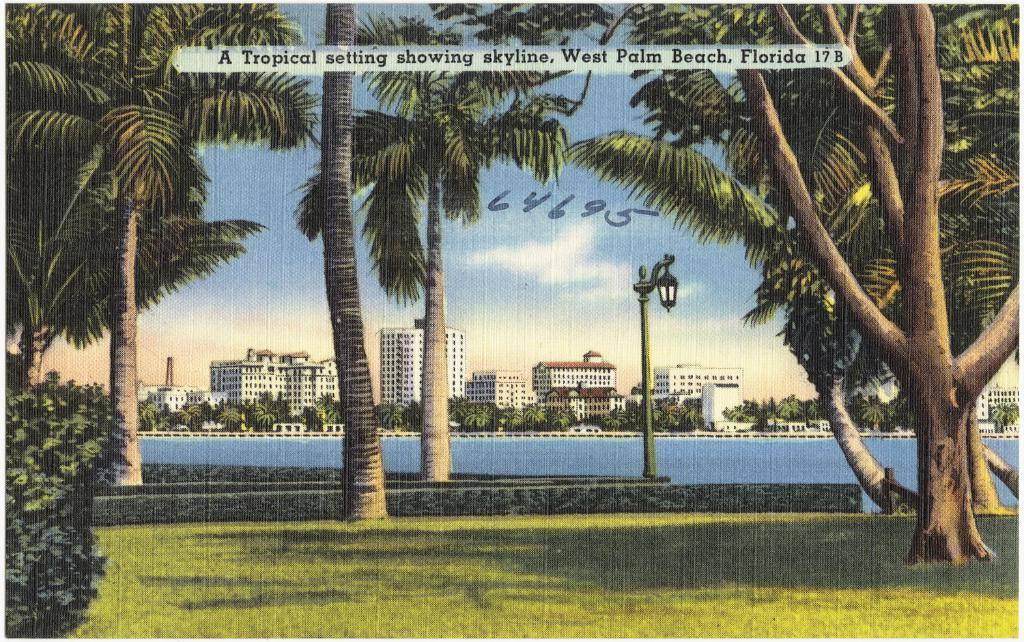What type of artwork is depicted in the image? The image is a painting. What is one specific object that can be seen in the painting? There is a light pole in the painting. What type of natural elements are present in the painting? There are trees, plants, grass, water, sky, and clouds in the painting. What type of man-made structures are present in the painting? There are buildings in the painting. Can you tell me how many laborers are working in the painting? There are no laborers present in the painting; it features a light pole, trees, plants, grass, water, buildings, sky, and clouds. What season is depicted in the painting? The painting does not depict a specific season, as there are no seasonal indicators such as leaves changing color or snow. 